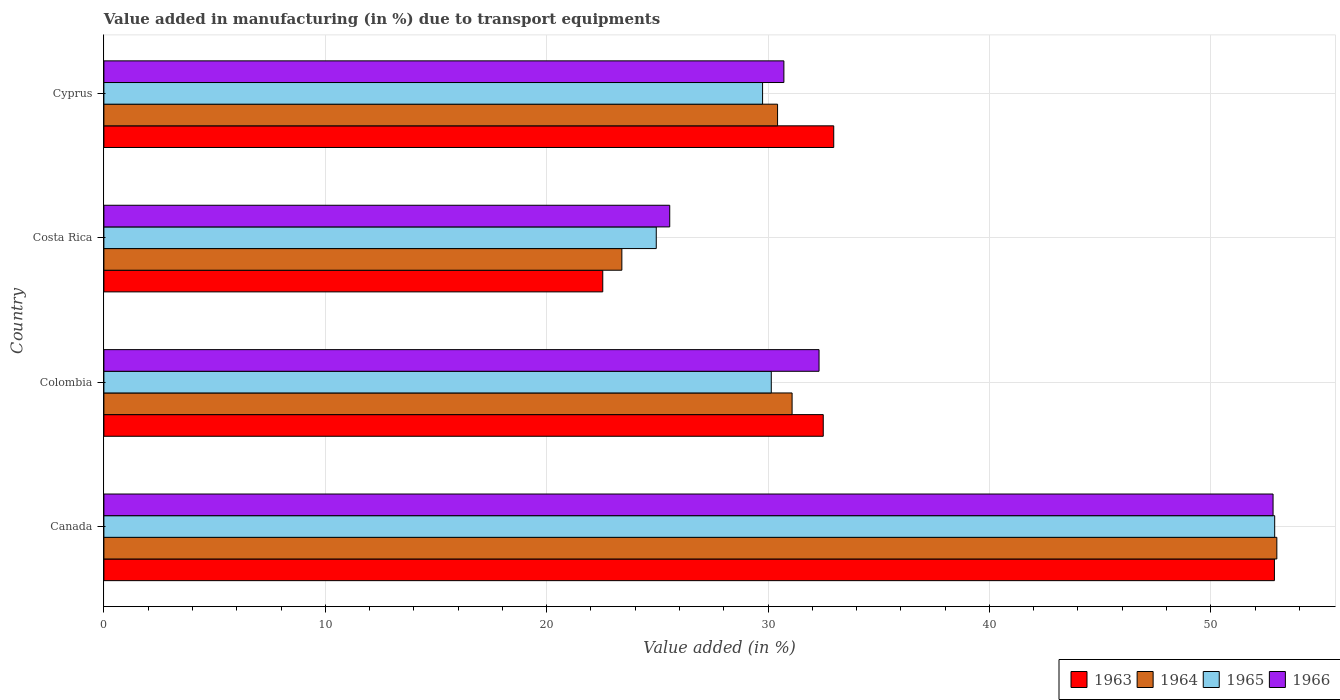How many different coloured bars are there?
Make the answer very short. 4. How many bars are there on the 2nd tick from the top?
Ensure brevity in your answer.  4. How many bars are there on the 3rd tick from the bottom?
Offer a very short reply. 4. What is the percentage of value added in manufacturing due to transport equipments in 1965 in Colombia?
Keep it short and to the point. 30.15. Across all countries, what is the maximum percentage of value added in manufacturing due to transport equipments in 1964?
Your response must be concise. 52.98. Across all countries, what is the minimum percentage of value added in manufacturing due to transport equipments in 1965?
Your response must be concise. 24.95. What is the total percentage of value added in manufacturing due to transport equipments in 1966 in the graph?
Provide a succinct answer. 141.39. What is the difference between the percentage of value added in manufacturing due to transport equipments in 1963 in Canada and that in Colombia?
Your answer should be compact. 20.38. What is the difference between the percentage of value added in manufacturing due to transport equipments in 1964 in Colombia and the percentage of value added in manufacturing due to transport equipments in 1966 in Costa Rica?
Make the answer very short. 5.53. What is the average percentage of value added in manufacturing due to transport equipments in 1966 per country?
Keep it short and to the point. 35.35. What is the difference between the percentage of value added in manufacturing due to transport equipments in 1963 and percentage of value added in manufacturing due to transport equipments in 1966 in Cyprus?
Provide a short and direct response. 2.25. What is the ratio of the percentage of value added in manufacturing due to transport equipments in 1966 in Costa Rica to that in Cyprus?
Offer a terse response. 0.83. Is the percentage of value added in manufacturing due to transport equipments in 1965 in Canada less than that in Cyprus?
Your answer should be very brief. No. What is the difference between the highest and the second highest percentage of value added in manufacturing due to transport equipments in 1966?
Your answer should be compact. 20.51. What is the difference between the highest and the lowest percentage of value added in manufacturing due to transport equipments in 1964?
Give a very brief answer. 29.59. In how many countries, is the percentage of value added in manufacturing due to transport equipments in 1965 greater than the average percentage of value added in manufacturing due to transport equipments in 1965 taken over all countries?
Your answer should be very brief. 1. Is the sum of the percentage of value added in manufacturing due to transport equipments in 1965 in Colombia and Cyprus greater than the maximum percentage of value added in manufacturing due to transport equipments in 1964 across all countries?
Offer a terse response. Yes. What does the 3rd bar from the top in Colombia represents?
Provide a short and direct response. 1964. What does the 2nd bar from the bottom in Canada represents?
Provide a succinct answer. 1964. Is it the case that in every country, the sum of the percentage of value added in manufacturing due to transport equipments in 1966 and percentage of value added in manufacturing due to transport equipments in 1963 is greater than the percentage of value added in manufacturing due to transport equipments in 1964?
Keep it short and to the point. Yes. How many bars are there?
Your answer should be very brief. 16. What is the difference between two consecutive major ticks on the X-axis?
Your answer should be compact. 10. Are the values on the major ticks of X-axis written in scientific E-notation?
Ensure brevity in your answer.  No. Does the graph contain any zero values?
Provide a short and direct response. No. How many legend labels are there?
Keep it short and to the point. 4. How are the legend labels stacked?
Ensure brevity in your answer.  Horizontal. What is the title of the graph?
Offer a very short reply. Value added in manufacturing (in %) due to transport equipments. Does "2000" appear as one of the legend labels in the graph?
Your answer should be very brief. No. What is the label or title of the X-axis?
Keep it short and to the point. Value added (in %). What is the label or title of the Y-axis?
Ensure brevity in your answer.  Country. What is the Value added (in %) of 1963 in Canada?
Offer a terse response. 52.87. What is the Value added (in %) of 1964 in Canada?
Ensure brevity in your answer.  52.98. What is the Value added (in %) of 1965 in Canada?
Offer a terse response. 52.89. What is the Value added (in %) of 1966 in Canada?
Offer a terse response. 52.81. What is the Value added (in %) of 1963 in Colombia?
Your answer should be compact. 32.49. What is the Value added (in %) in 1964 in Colombia?
Provide a short and direct response. 31.09. What is the Value added (in %) in 1965 in Colombia?
Offer a very short reply. 30.15. What is the Value added (in %) in 1966 in Colombia?
Provide a short and direct response. 32.3. What is the Value added (in %) in 1963 in Costa Rica?
Provide a succinct answer. 22.53. What is the Value added (in %) of 1964 in Costa Rica?
Give a very brief answer. 23.4. What is the Value added (in %) in 1965 in Costa Rica?
Your answer should be very brief. 24.95. What is the Value added (in %) of 1966 in Costa Rica?
Offer a very short reply. 25.56. What is the Value added (in %) of 1963 in Cyprus?
Make the answer very short. 32.97. What is the Value added (in %) in 1964 in Cyprus?
Your response must be concise. 30.43. What is the Value added (in %) of 1965 in Cyprus?
Your answer should be very brief. 29.75. What is the Value added (in %) of 1966 in Cyprus?
Your answer should be very brief. 30.72. Across all countries, what is the maximum Value added (in %) of 1963?
Your response must be concise. 52.87. Across all countries, what is the maximum Value added (in %) of 1964?
Your answer should be very brief. 52.98. Across all countries, what is the maximum Value added (in %) in 1965?
Ensure brevity in your answer.  52.89. Across all countries, what is the maximum Value added (in %) in 1966?
Offer a very short reply. 52.81. Across all countries, what is the minimum Value added (in %) of 1963?
Make the answer very short. 22.53. Across all countries, what is the minimum Value added (in %) in 1964?
Your answer should be very brief. 23.4. Across all countries, what is the minimum Value added (in %) in 1965?
Your answer should be compact. 24.95. Across all countries, what is the minimum Value added (in %) in 1966?
Provide a short and direct response. 25.56. What is the total Value added (in %) of 1963 in the graph?
Your answer should be compact. 140.87. What is the total Value added (in %) of 1964 in the graph?
Your response must be concise. 137.89. What is the total Value added (in %) in 1965 in the graph?
Your answer should be very brief. 137.73. What is the total Value added (in %) of 1966 in the graph?
Your response must be concise. 141.39. What is the difference between the Value added (in %) in 1963 in Canada and that in Colombia?
Offer a terse response. 20.38. What is the difference between the Value added (in %) in 1964 in Canada and that in Colombia?
Give a very brief answer. 21.9. What is the difference between the Value added (in %) of 1965 in Canada and that in Colombia?
Offer a terse response. 22.74. What is the difference between the Value added (in %) in 1966 in Canada and that in Colombia?
Offer a very short reply. 20.51. What is the difference between the Value added (in %) of 1963 in Canada and that in Costa Rica?
Offer a very short reply. 30.34. What is the difference between the Value added (in %) in 1964 in Canada and that in Costa Rica?
Offer a very short reply. 29.59. What is the difference between the Value added (in %) of 1965 in Canada and that in Costa Rica?
Give a very brief answer. 27.93. What is the difference between the Value added (in %) in 1966 in Canada and that in Costa Rica?
Offer a terse response. 27.25. What is the difference between the Value added (in %) of 1963 in Canada and that in Cyprus?
Provide a succinct answer. 19.91. What is the difference between the Value added (in %) in 1964 in Canada and that in Cyprus?
Provide a succinct answer. 22.55. What is the difference between the Value added (in %) of 1965 in Canada and that in Cyprus?
Ensure brevity in your answer.  23.13. What is the difference between the Value added (in %) in 1966 in Canada and that in Cyprus?
Make the answer very short. 22.1. What is the difference between the Value added (in %) in 1963 in Colombia and that in Costa Rica?
Ensure brevity in your answer.  9.96. What is the difference between the Value added (in %) of 1964 in Colombia and that in Costa Rica?
Ensure brevity in your answer.  7.69. What is the difference between the Value added (in %) of 1965 in Colombia and that in Costa Rica?
Provide a succinct answer. 5.2. What is the difference between the Value added (in %) of 1966 in Colombia and that in Costa Rica?
Offer a very short reply. 6.74. What is the difference between the Value added (in %) in 1963 in Colombia and that in Cyprus?
Provide a succinct answer. -0.47. What is the difference between the Value added (in %) of 1964 in Colombia and that in Cyprus?
Keep it short and to the point. 0.66. What is the difference between the Value added (in %) in 1965 in Colombia and that in Cyprus?
Make the answer very short. 0.39. What is the difference between the Value added (in %) of 1966 in Colombia and that in Cyprus?
Make the answer very short. 1.59. What is the difference between the Value added (in %) in 1963 in Costa Rica and that in Cyprus?
Your response must be concise. -10.43. What is the difference between the Value added (in %) in 1964 in Costa Rica and that in Cyprus?
Give a very brief answer. -7.03. What is the difference between the Value added (in %) in 1965 in Costa Rica and that in Cyprus?
Offer a very short reply. -4.8. What is the difference between the Value added (in %) of 1966 in Costa Rica and that in Cyprus?
Provide a short and direct response. -5.16. What is the difference between the Value added (in %) in 1963 in Canada and the Value added (in %) in 1964 in Colombia?
Keep it short and to the point. 21.79. What is the difference between the Value added (in %) in 1963 in Canada and the Value added (in %) in 1965 in Colombia?
Make the answer very short. 22.73. What is the difference between the Value added (in %) of 1963 in Canada and the Value added (in %) of 1966 in Colombia?
Your answer should be compact. 20.57. What is the difference between the Value added (in %) in 1964 in Canada and the Value added (in %) in 1965 in Colombia?
Your answer should be very brief. 22.84. What is the difference between the Value added (in %) in 1964 in Canada and the Value added (in %) in 1966 in Colombia?
Offer a terse response. 20.68. What is the difference between the Value added (in %) of 1965 in Canada and the Value added (in %) of 1966 in Colombia?
Provide a short and direct response. 20.58. What is the difference between the Value added (in %) of 1963 in Canada and the Value added (in %) of 1964 in Costa Rica?
Provide a succinct answer. 29.48. What is the difference between the Value added (in %) in 1963 in Canada and the Value added (in %) in 1965 in Costa Rica?
Make the answer very short. 27.92. What is the difference between the Value added (in %) in 1963 in Canada and the Value added (in %) in 1966 in Costa Rica?
Ensure brevity in your answer.  27.31. What is the difference between the Value added (in %) in 1964 in Canada and the Value added (in %) in 1965 in Costa Rica?
Provide a succinct answer. 28.03. What is the difference between the Value added (in %) in 1964 in Canada and the Value added (in %) in 1966 in Costa Rica?
Your answer should be compact. 27.42. What is the difference between the Value added (in %) of 1965 in Canada and the Value added (in %) of 1966 in Costa Rica?
Offer a very short reply. 27.33. What is the difference between the Value added (in %) of 1963 in Canada and the Value added (in %) of 1964 in Cyprus?
Offer a very short reply. 22.44. What is the difference between the Value added (in %) in 1963 in Canada and the Value added (in %) in 1965 in Cyprus?
Make the answer very short. 23.12. What is the difference between the Value added (in %) of 1963 in Canada and the Value added (in %) of 1966 in Cyprus?
Ensure brevity in your answer.  22.16. What is the difference between the Value added (in %) of 1964 in Canada and the Value added (in %) of 1965 in Cyprus?
Your answer should be very brief. 23.23. What is the difference between the Value added (in %) of 1964 in Canada and the Value added (in %) of 1966 in Cyprus?
Make the answer very short. 22.27. What is the difference between the Value added (in %) of 1965 in Canada and the Value added (in %) of 1966 in Cyprus?
Your response must be concise. 22.17. What is the difference between the Value added (in %) of 1963 in Colombia and the Value added (in %) of 1964 in Costa Rica?
Your answer should be compact. 9.1. What is the difference between the Value added (in %) in 1963 in Colombia and the Value added (in %) in 1965 in Costa Rica?
Offer a very short reply. 7.54. What is the difference between the Value added (in %) of 1963 in Colombia and the Value added (in %) of 1966 in Costa Rica?
Give a very brief answer. 6.93. What is the difference between the Value added (in %) of 1964 in Colombia and the Value added (in %) of 1965 in Costa Rica?
Offer a terse response. 6.14. What is the difference between the Value added (in %) in 1964 in Colombia and the Value added (in %) in 1966 in Costa Rica?
Provide a succinct answer. 5.53. What is the difference between the Value added (in %) of 1965 in Colombia and the Value added (in %) of 1966 in Costa Rica?
Your response must be concise. 4.59. What is the difference between the Value added (in %) in 1963 in Colombia and the Value added (in %) in 1964 in Cyprus?
Provide a short and direct response. 2.06. What is the difference between the Value added (in %) in 1963 in Colombia and the Value added (in %) in 1965 in Cyprus?
Keep it short and to the point. 2.74. What is the difference between the Value added (in %) in 1963 in Colombia and the Value added (in %) in 1966 in Cyprus?
Offer a very short reply. 1.78. What is the difference between the Value added (in %) of 1964 in Colombia and the Value added (in %) of 1965 in Cyprus?
Keep it short and to the point. 1.33. What is the difference between the Value added (in %) in 1964 in Colombia and the Value added (in %) in 1966 in Cyprus?
Your answer should be compact. 0.37. What is the difference between the Value added (in %) of 1965 in Colombia and the Value added (in %) of 1966 in Cyprus?
Keep it short and to the point. -0.57. What is the difference between the Value added (in %) of 1963 in Costa Rica and the Value added (in %) of 1964 in Cyprus?
Ensure brevity in your answer.  -7.9. What is the difference between the Value added (in %) of 1963 in Costa Rica and the Value added (in %) of 1965 in Cyprus?
Ensure brevity in your answer.  -7.22. What is the difference between the Value added (in %) in 1963 in Costa Rica and the Value added (in %) in 1966 in Cyprus?
Your response must be concise. -8.18. What is the difference between the Value added (in %) in 1964 in Costa Rica and the Value added (in %) in 1965 in Cyprus?
Your response must be concise. -6.36. What is the difference between the Value added (in %) in 1964 in Costa Rica and the Value added (in %) in 1966 in Cyprus?
Offer a terse response. -7.32. What is the difference between the Value added (in %) in 1965 in Costa Rica and the Value added (in %) in 1966 in Cyprus?
Keep it short and to the point. -5.77. What is the average Value added (in %) of 1963 per country?
Your answer should be compact. 35.22. What is the average Value added (in %) in 1964 per country?
Give a very brief answer. 34.47. What is the average Value added (in %) of 1965 per country?
Your response must be concise. 34.43. What is the average Value added (in %) of 1966 per country?
Your answer should be compact. 35.35. What is the difference between the Value added (in %) in 1963 and Value added (in %) in 1964 in Canada?
Give a very brief answer. -0.11. What is the difference between the Value added (in %) in 1963 and Value added (in %) in 1965 in Canada?
Offer a terse response. -0.01. What is the difference between the Value added (in %) in 1963 and Value added (in %) in 1966 in Canada?
Ensure brevity in your answer.  0.06. What is the difference between the Value added (in %) in 1964 and Value added (in %) in 1965 in Canada?
Ensure brevity in your answer.  0.1. What is the difference between the Value added (in %) in 1964 and Value added (in %) in 1966 in Canada?
Provide a succinct answer. 0.17. What is the difference between the Value added (in %) in 1965 and Value added (in %) in 1966 in Canada?
Give a very brief answer. 0.07. What is the difference between the Value added (in %) in 1963 and Value added (in %) in 1964 in Colombia?
Offer a very short reply. 1.41. What is the difference between the Value added (in %) of 1963 and Value added (in %) of 1965 in Colombia?
Keep it short and to the point. 2.35. What is the difference between the Value added (in %) in 1963 and Value added (in %) in 1966 in Colombia?
Your response must be concise. 0.19. What is the difference between the Value added (in %) of 1964 and Value added (in %) of 1965 in Colombia?
Give a very brief answer. 0.94. What is the difference between the Value added (in %) of 1964 and Value added (in %) of 1966 in Colombia?
Keep it short and to the point. -1.22. What is the difference between the Value added (in %) in 1965 and Value added (in %) in 1966 in Colombia?
Give a very brief answer. -2.16. What is the difference between the Value added (in %) in 1963 and Value added (in %) in 1964 in Costa Rica?
Your response must be concise. -0.86. What is the difference between the Value added (in %) of 1963 and Value added (in %) of 1965 in Costa Rica?
Provide a succinct answer. -2.42. What is the difference between the Value added (in %) of 1963 and Value added (in %) of 1966 in Costa Rica?
Offer a very short reply. -3.03. What is the difference between the Value added (in %) of 1964 and Value added (in %) of 1965 in Costa Rica?
Your answer should be very brief. -1.55. What is the difference between the Value added (in %) in 1964 and Value added (in %) in 1966 in Costa Rica?
Give a very brief answer. -2.16. What is the difference between the Value added (in %) of 1965 and Value added (in %) of 1966 in Costa Rica?
Ensure brevity in your answer.  -0.61. What is the difference between the Value added (in %) in 1963 and Value added (in %) in 1964 in Cyprus?
Keep it short and to the point. 2.54. What is the difference between the Value added (in %) of 1963 and Value added (in %) of 1965 in Cyprus?
Offer a very short reply. 3.21. What is the difference between the Value added (in %) in 1963 and Value added (in %) in 1966 in Cyprus?
Offer a terse response. 2.25. What is the difference between the Value added (in %) in 1964 and Value added (in %) in 1965 in Cyprus?
Your answer should be very brief. 0.68. What is the difference between the Value added (in %) in 1964 and Value added (in %) in 1966 in Cyprus?
Your answer should be compact. -0.29. What is the difference between the Value added (in %) of 1965 and Value added (in %) of 1966 in Cyprus?
Make the answer very short. -0.96. What is the ratio of the Value added (in %) in 1963 in Canada to that in Colombia?
Your answer should be compact. 1.63. What is the ratio of the Value added (in %) in 1964 in Canada to that in Colombia?
Offer a very short reply. 1.7. What is the ratio of the Value added (in %) in 1965 in Canada to that in Colombia?
Ensure brevity in your answer.  1.75. What is the ratio of the Value added (in %) of 1966 in Canada to that in Colombia?
Keep it short and to the point. 1.63. What is the ratio of the Value added (in %) in 1963 in Canada to that in Costa Rica?
Ensure brevity in your answer.  2.35. What is the ratio of the Value added (in %) of 1964 in Canada to that in Costa Rica?
Keep it short and to the point. 2.26. What is the ratio of the Value added (in %) of 1965 in Canada to that in Costa Rica?
Keep it short and to the point. 2.12. What is the ratio of the Value added (in %) of 1966 in Canada to that in Costa Rica?
Your answer should be compact. 2.07. What is the ratio of the Value added (in %) of 1963 in Canada to that in Cyprus?
Provide a succinct answer. 1.6. What is the ratio of the Value added (in %) in 1964 in Canada to that in Cyprus?
Give a very brief answer. 1.74. What is the ratio of the Value added (in %) of 1965 in Canada to that in Cyprus?
Your answer should be compact. 1.78. What is the ratio of the Value added (in %) of 1966 in Canada to that in Cyprus?
Your response must be concise. 1.72. What is the ratio of the Value added (in %) in 1963 in Colombia to that in Costa Rica?
Offer a very short reply. 1.44. What is the ratio of the Value added (in %) of 1964 in Colombia to that in Costa Rica?
Offer a terse response. 1.33. What is the ratio of the Value added (in %) in 1965 in Colombia to that in Costa Rica?
Make the answer very short. 1.21. What is the ratio of the Value added (in %) in 1966 in Colombia to that in Costa Rica?
Provide a succinct answer. 1.26. What is the ratio of the Value added (in %) in 1963 in Colombia to that in Cyprus?
Provide a short and direct response. 0.99. What is the ratio of the Value added (in %) in 1964 in Colombia to that in Cyprus?
Make the answer very short. 1.02. What is the ratio of the Value added (in %) in 1965 in Colombia to that in Cyprus?
Provide a succinct answer. 1.01. What is the ratio of the Value added (in %) of 1966 in Colombia to that in Cyprus?
Offer a terse response. 1.05. What is the ratio of the Value added (in %) in 1963 in Costa Rica to that in Cyprus?
Your response must be concise. 0.68. What is the ratio of the Value added (in %) of 1964 in Costa Rica to that in Cyprus?
Provide a short and direct response. 0.77. What is the ratio of the Value added (in %) in 1965 in Costa Rica to that in Cyprus?
Give a very brief answer. 0.84. What is the ratio of the Value added (in %) in 1966 in Costa Rica to that in Cyprus?
Your answer should be very brief. 0.83. What is the difference between the highest and the second highest Value added (in %) in 1963?
Your response must be concise. 19.91. What is the difference between the highest and the second highest Value added (in %) of 1964?
Your answer should be compact. 21.9. What is the difference between the highest and the second highest Value added (in %) of 1965?
Offer a terse response. 22.74. What is the difference between the highest and the second highest Value added (in %) in 1966?
Your response must be concise. 20.51. What is the difference between the highest and the lowest Value added (in %) of 1963?
Provide a succinct answer. 30.34. What is the difference between the highest and the lowest Value added (in %) in 1964?
Your response must be concise. 29.59. What is the difference between the highest and the lowest Value added (in %) of 1965?
Keep it short and to the point. 27.93. What is the difference between the highest and the lowest Value added (in %) of 1966?
Offer a terse response. 27.25. 